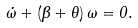Convert formula to latex. <formula><loc_0><loc_0><loc_500><loc_500>\dot { \omega } + ( \beta + \theta ) \, \omega = 0 .</formula> 